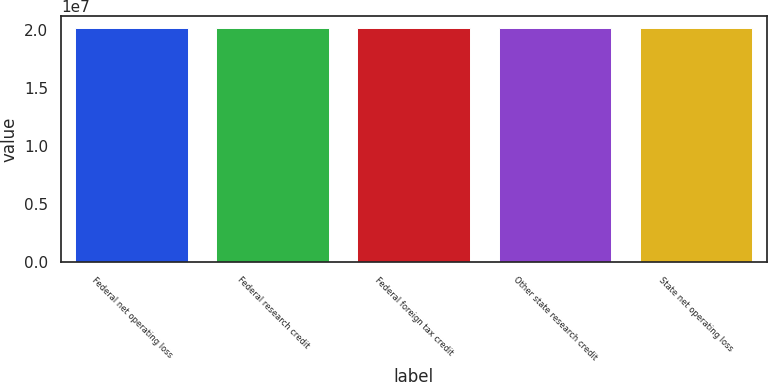Convert chart. <chart><loc_0><loc_0><loc_500><loc_500><bar_chart><fcel>Federal net operating loss<fcel>Federal research credit<fcel>Federal foreign tax credit<fcel>Other state research credit<fcel>State net operating loss<nl><fcel>2.0165e+07<fcel>2.0192e+07<fcel>2.0172e+07<fcel>2.0162e+07<fcel>2.0168e+07<nl></chart> 